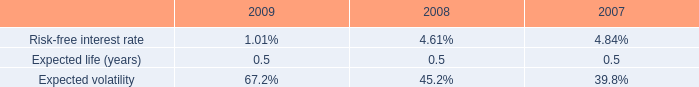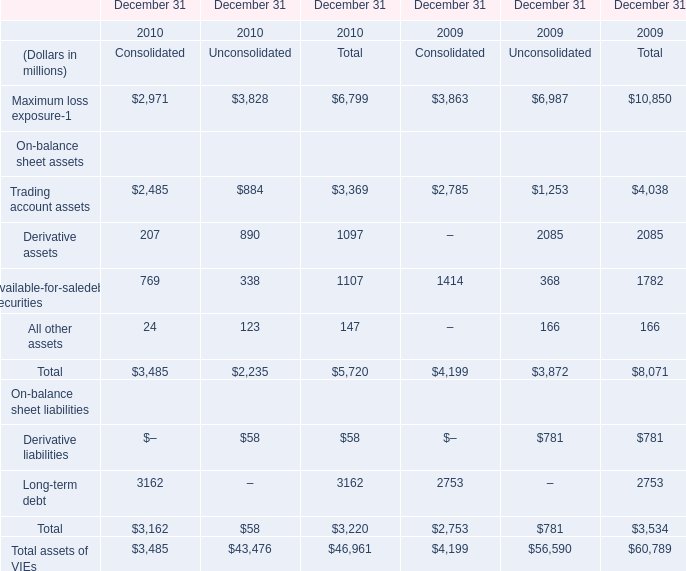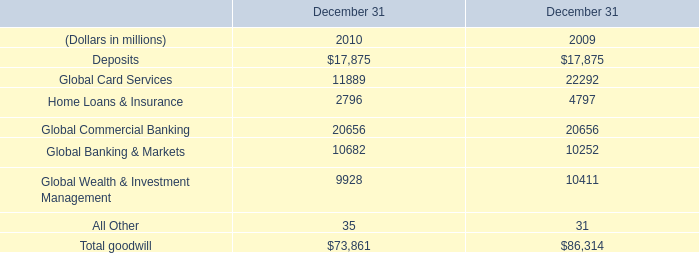how many shares of common stock were issued during 2007? 
Computations: (5000000 + 80068)
Answer: 5080068.0. 